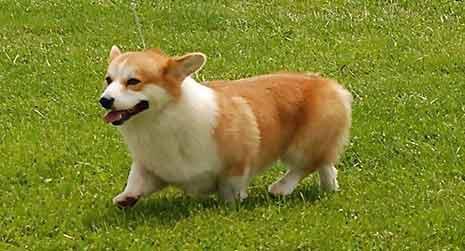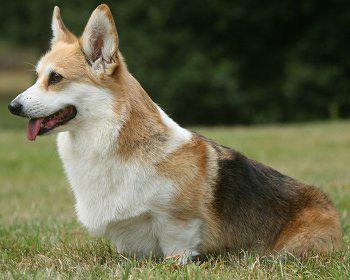The first image is the image on the left, the second image is the image on the right. Assess this claim about the two images: "There is exactly one dog facing left in the image on the left.". Correct or not? Answer yes or no. Yes. The first image is the image on the left, the second image is the image on the right. Assess this claim about the two images: "One of the images contains a dog that is sitting.". Correct or not? Answer yes or no. Yes. 